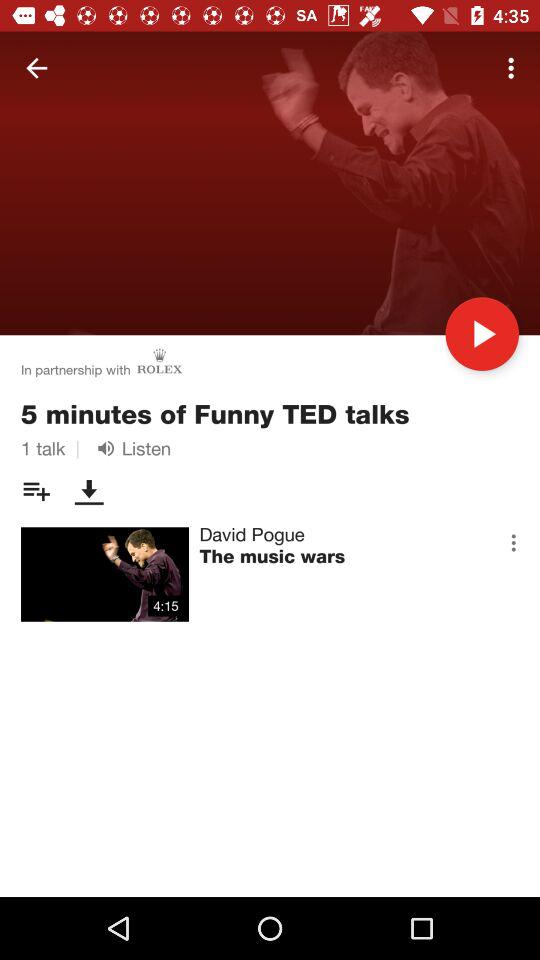What is the duration of "The music wars" TED talk? The duration of "The music wars" TED talk is 4 minutes 15 seconds. 